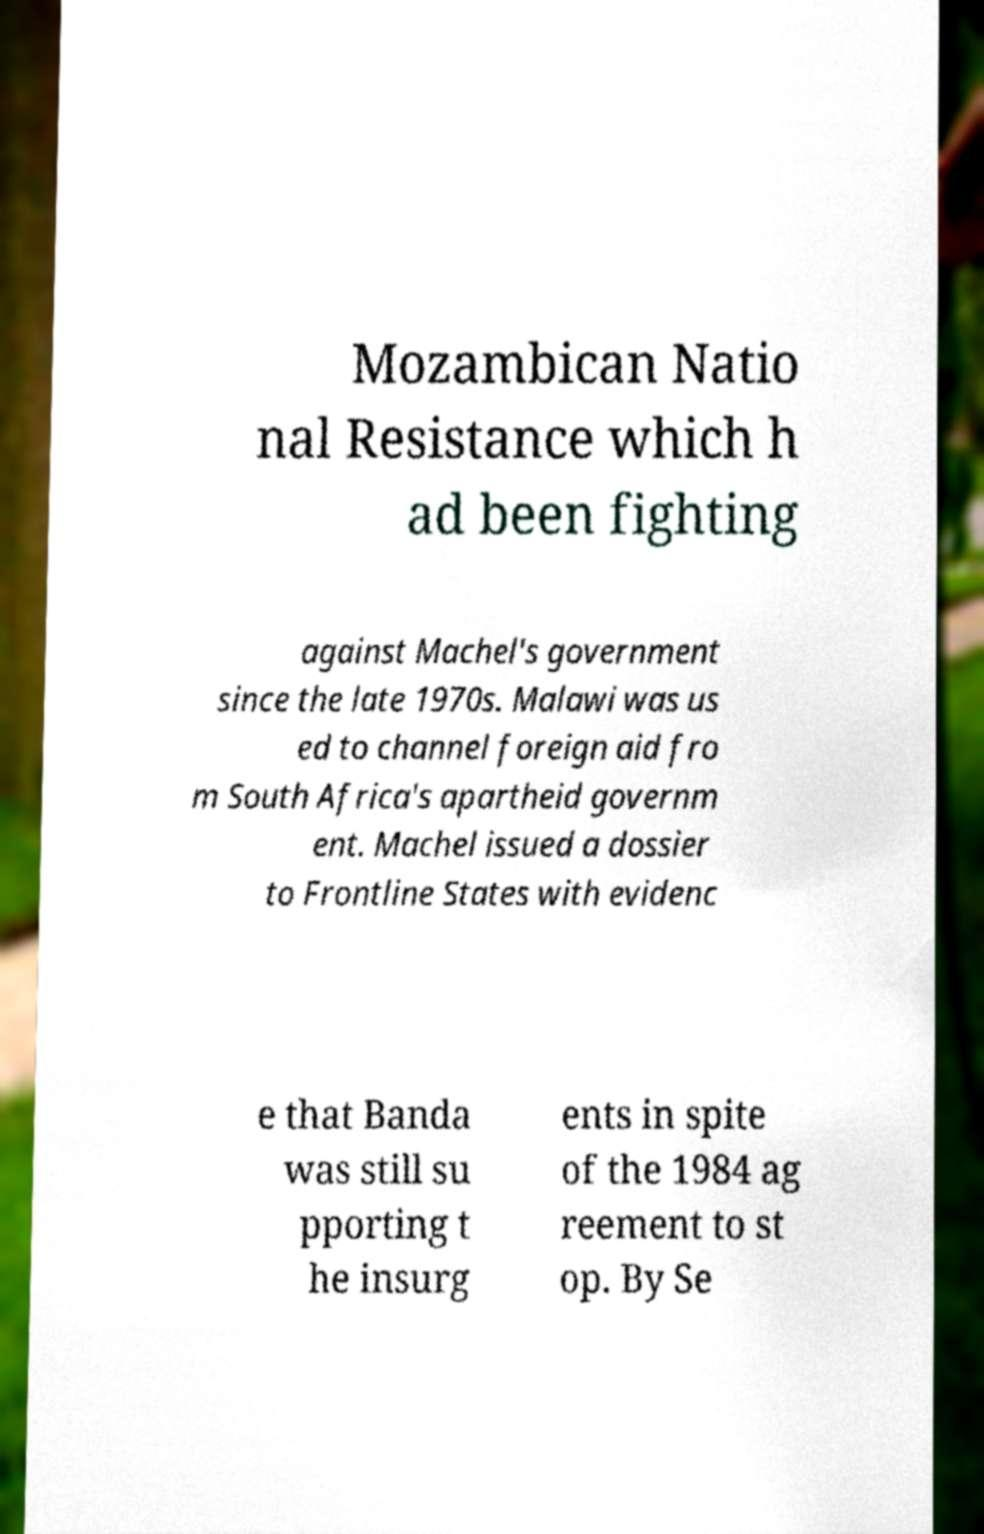There's text embedded in this image that I need extracted. Can you transcribe it verbatim? Mozambican Natio nal Resistance which h ad been fighting against Machel's government since the late 1970s. Malawi was us ed to channel foreign aid fro m South Africa's apartheid governm ent. Machel issued a dossier to Frontline States with evidenc e that Banda was still su pporting t he insurg ents in spite of the 1984 ag reement to st op. By Se 